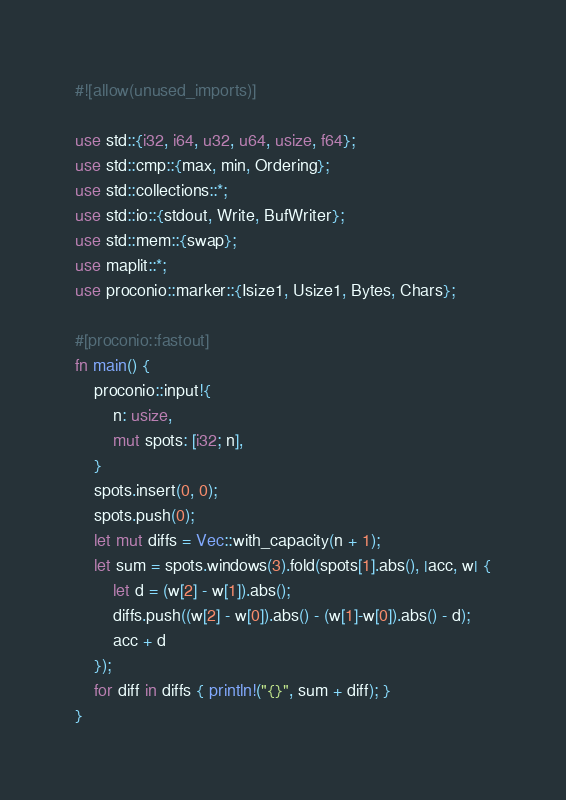Convert code to text. <code><loc_0><loc_0><loc_500><loc_500><_Rust_>#![allow(unused_imports)]

use std::{i32, i64, u32, u64, usize, f64};
use std::cmp::{max, min, Ordering};
use std::collections::*;
use std::io::{stdout, Write, BufWriter};
use std::mem::{swap};
use maplit::*;
use proconio::marker::{Isize1, Usize1, Bytes, Chars};

#[proconio::fastout]
fn main() {
    proconio::input!{
        n: usize,
        mut spots: [i32; n],
    }
    spots.insert(0, 0);
    spots.push(0);
    let mut diffs = Vec::with_capacity(n + 1);
    let sum = spots.windows(3).fold(spots[1].abs(), |acc, w| {
        let d = (w[2] - w[1]).abs();
        diffs.push((w[2] - w[0]).abs() - (w[1]-w[0]).abs() - d);
        acc + d
    });
    for diff in diffs { println!("{}", sum + diff); } 
}
</code> 